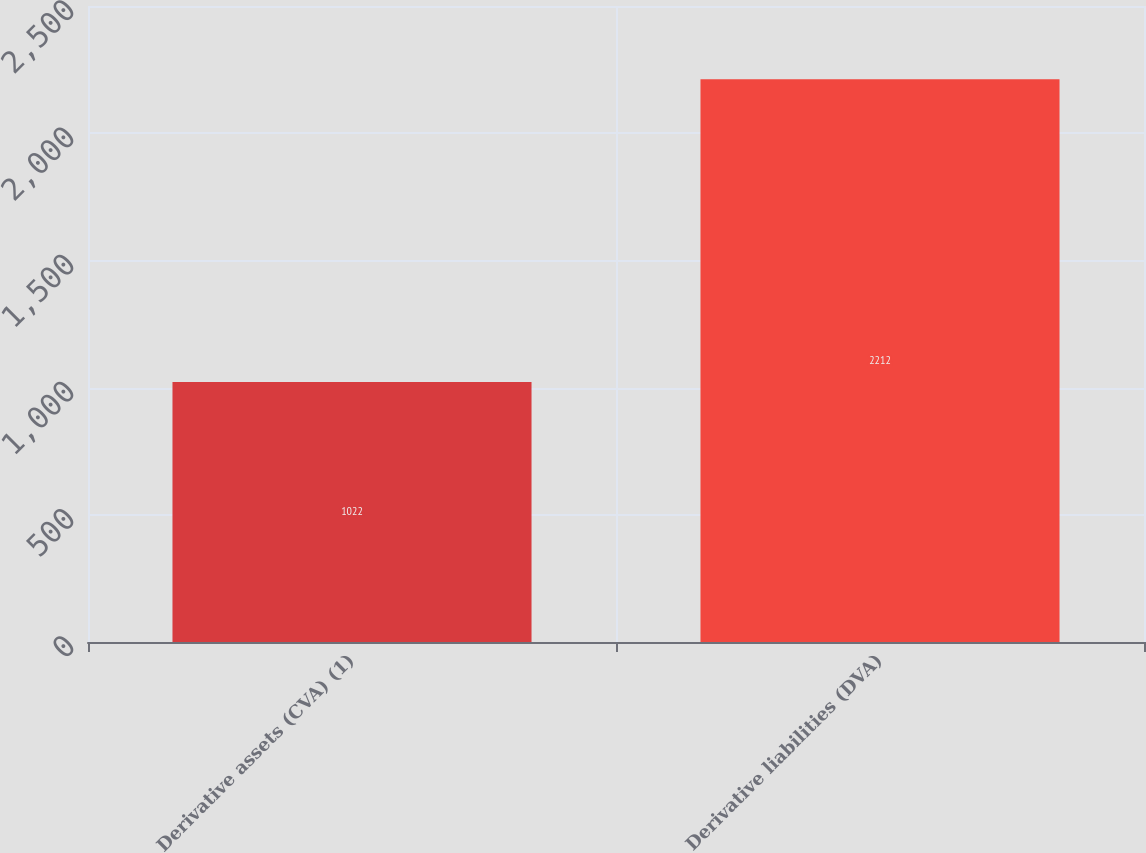Convert chart. <chart><loc_0><loc_0><loc_500><loc_500><bar_chart><fcel>Derivative assets (CVA) (1)<fcel>Derivative liabilities (DVA)<nl><fcel>1022<fcel>2212<nl></chart> 